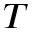Convert formula to latex. <formula><loc_0><loc_0><loc_500><loc_500>T</formula> 